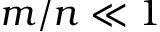Convert formula to latex. <formula><loc_0><loc_0><loc_500><loc_500>m / n \ll 1</formula> 